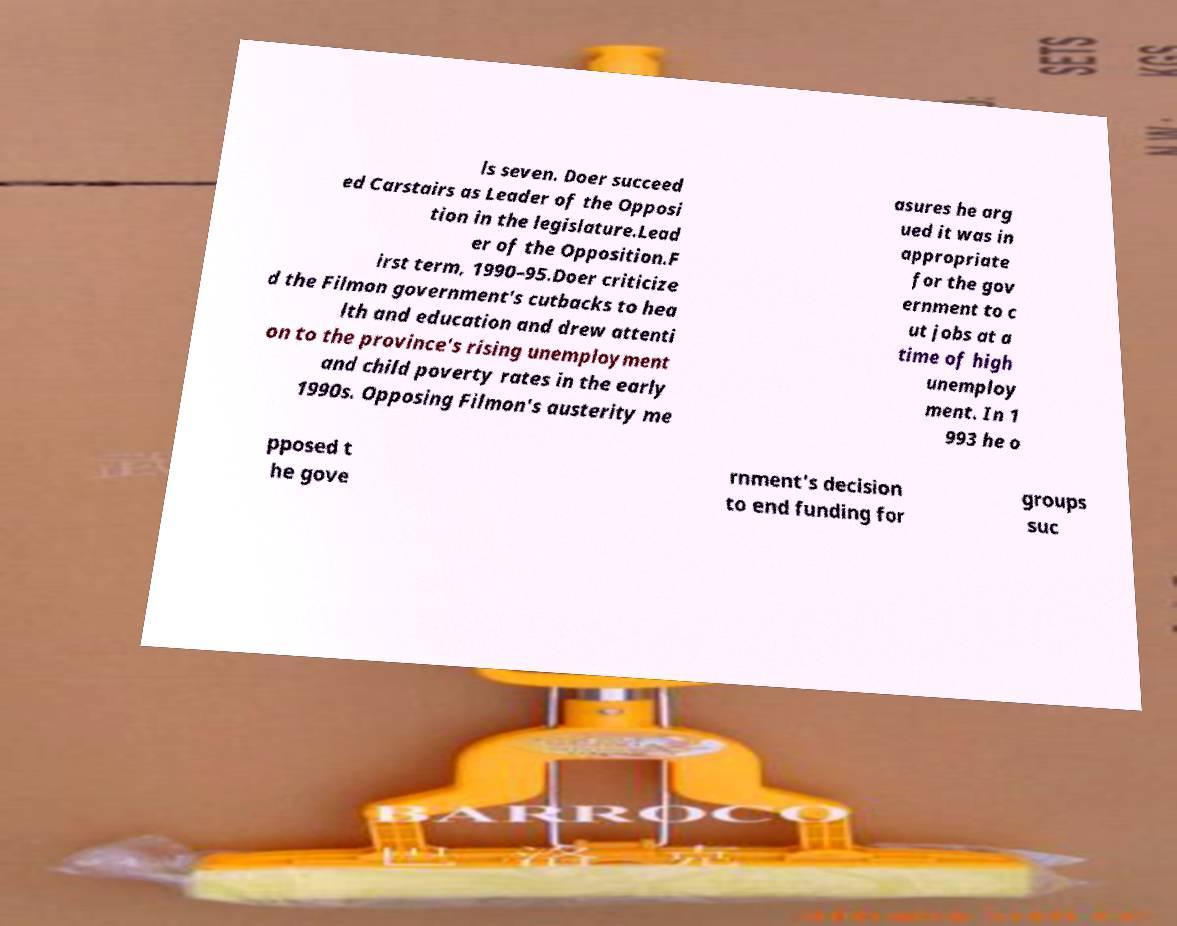There's text embedded in this image that I need extracted. Can you transcribe it verbatim? ls seven. Doer succeed ed Carstairs as Leader of the Opposi tion in the legislature.Lead er of the Opposition.F irst term, 1990–95.Doer criticize d the Filmon government's cutbacks to hea lth and education and drew attenti on to the province's rising unemployment and child poverty rates in the early 1990s. Opposing Filmon's austerity me asures he arg ued it was in appropriate for the gov ernment to c ut jobs at a time of high unemploy ment. In 1 993 he o pposed t he gove rnment's decision to end funding for groups suc 